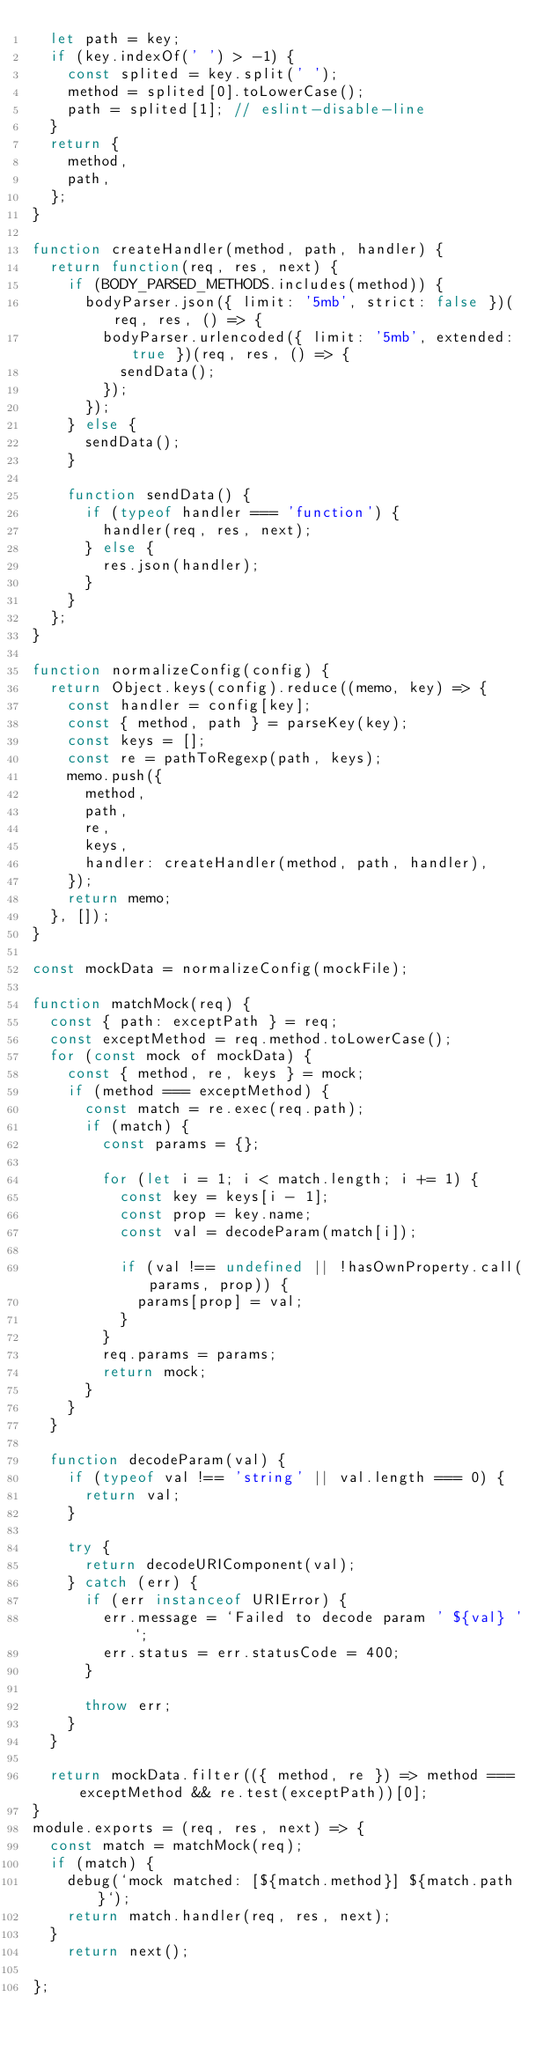<code> <loc_0><loc_0><loc_500><loc_500><_JavaScript_>  let path = key;
  if (key.indexOf(' ') > -1) {
    const splited = key.split(' ');
    method = splited[0].toLowerCase();
    path = splited[1]; // eslint-disable-line
  }
  return {
    method,
    path,
  };
}

function createHandler(method, path, handler) {
  return function(req, res, next) {
    if (BODY_PARSED_METHODS.includes(method)) {
      bodyParser.json({ limit: '5mb', strict: false })(req, res, () => {
        bodyParser.urlencoded({ limit: '5mb', extended: true })(req, res, () => {
          sendData();
        });
      });
    } else {
      sendData();
    }

    function sendData() {
      if (typeof handler === 'function') {
        handler(req, res, next);
      } else {
        res.json(handler);
      }
    }
  };
}

function normalizeConfig(config) {
  return Object.keys(config).reduce((memo, key) => {
    const handler = config[key];
    const { method, path } = parseKey(key);
    const keys = [];
    const re = pathToRegexp(path, keys);
    memo.push({
      method,
      path,
      re,
      keys,
      handler: createHandler(method, path, handler),
    });
    return memo;
  }, []);
}

const mockData = normalizeConfig(mockFile);

function matchMock(req) {
  const { path: exceptPath } = req;
  const exceptMethod = req.method.toLowerCase();
  for (const mock of mockData) {
    const { method, re, keys } = mock;
    if (method === exceptMethod) {
      const match = re.exec(req.path);
      if (match) {
        const params = {};

        for (let i = 1; i < match.length; i += 1) {
          const key = keys[i - 1];
          const prop = key.name;
          const val = decodeParam(match[i]);

          if (val !== undefined || !hasOwnProperty.call(params, prop)) {
            params[prop] = val;
          }
        }
        req.params = params;
        return mock;
      }
    }
  }

  function decodeParam(val) {
    if (typeof val !== 'string' || val.length === 0) {
      return val;
    }

    try {
      return decodeURIComponent(val);
    } catch (err) {
      if (err instanceof URIError) {
        err.message = `Failed to decode param ' ${val} '`;
        err.status = err.statusCode = 400;
      }

      throw err;
    }
  }

  return mockData.filter(({ method, re }) => method === exceptMethod && re.test(exceptPath))[0];
}
module.exports = (req, res, next) => {
  const match = matchMock(req);
  if (match) {
    debug(`mock matched: [${match.method}] ${match.path}`);
    return match.handler(req, res, next);
  } 
    return next();
  
};
</code> 